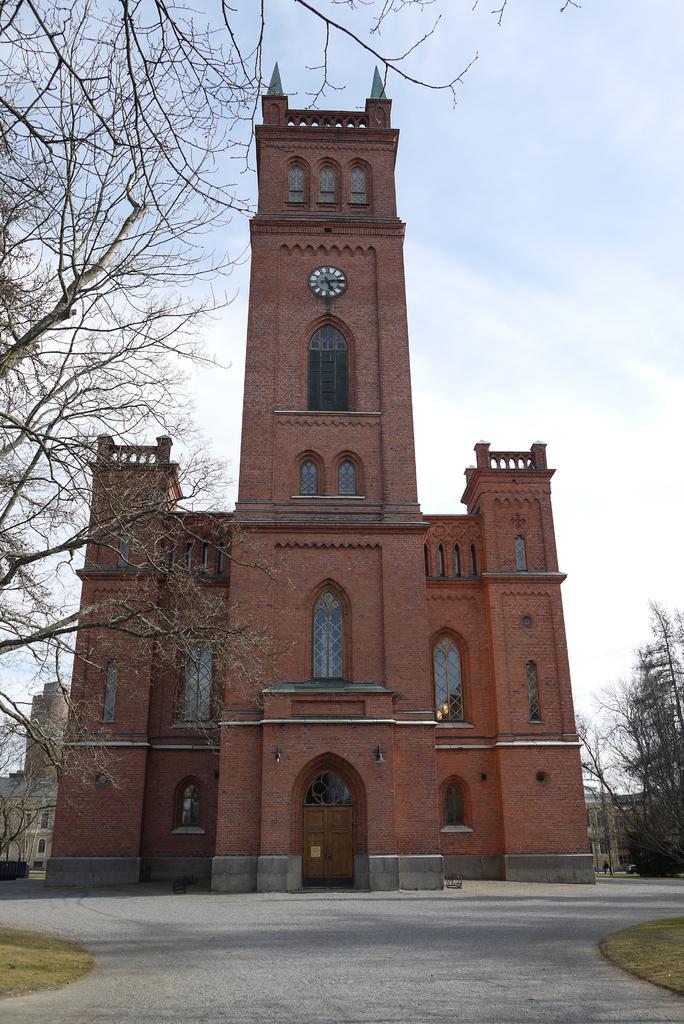How would you summarize this image in a sentence or two? This picture shows a building and we see o'clock on it and we see few buildings on the side and few trees and a blue cloudy Sky. 